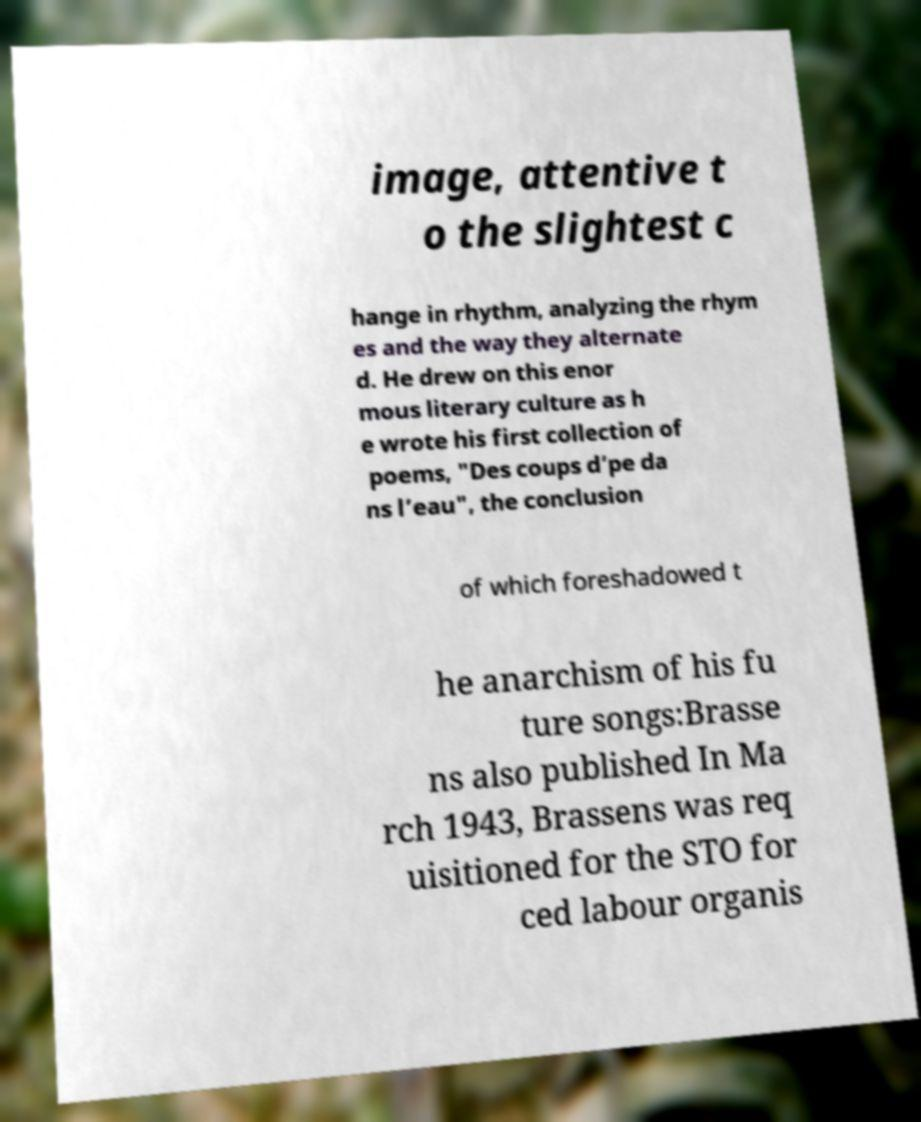For documentation purposes, I need the text within this image transcribed. Could you provide that? image, attentive t o the slightest c hange in rhythm, analyzing the rhym es and the way they alternate d. He drew on this enor mous literary culture as h e wrote his first collection of poems, "Des coups d’pe da ns l’eau", the conclusion of which foreshadowed t he anarchism of his fu ture songs:Brasse ns also published In Ma rch 1943, Brassens was req uisitioned for the STO for ced labour organis 